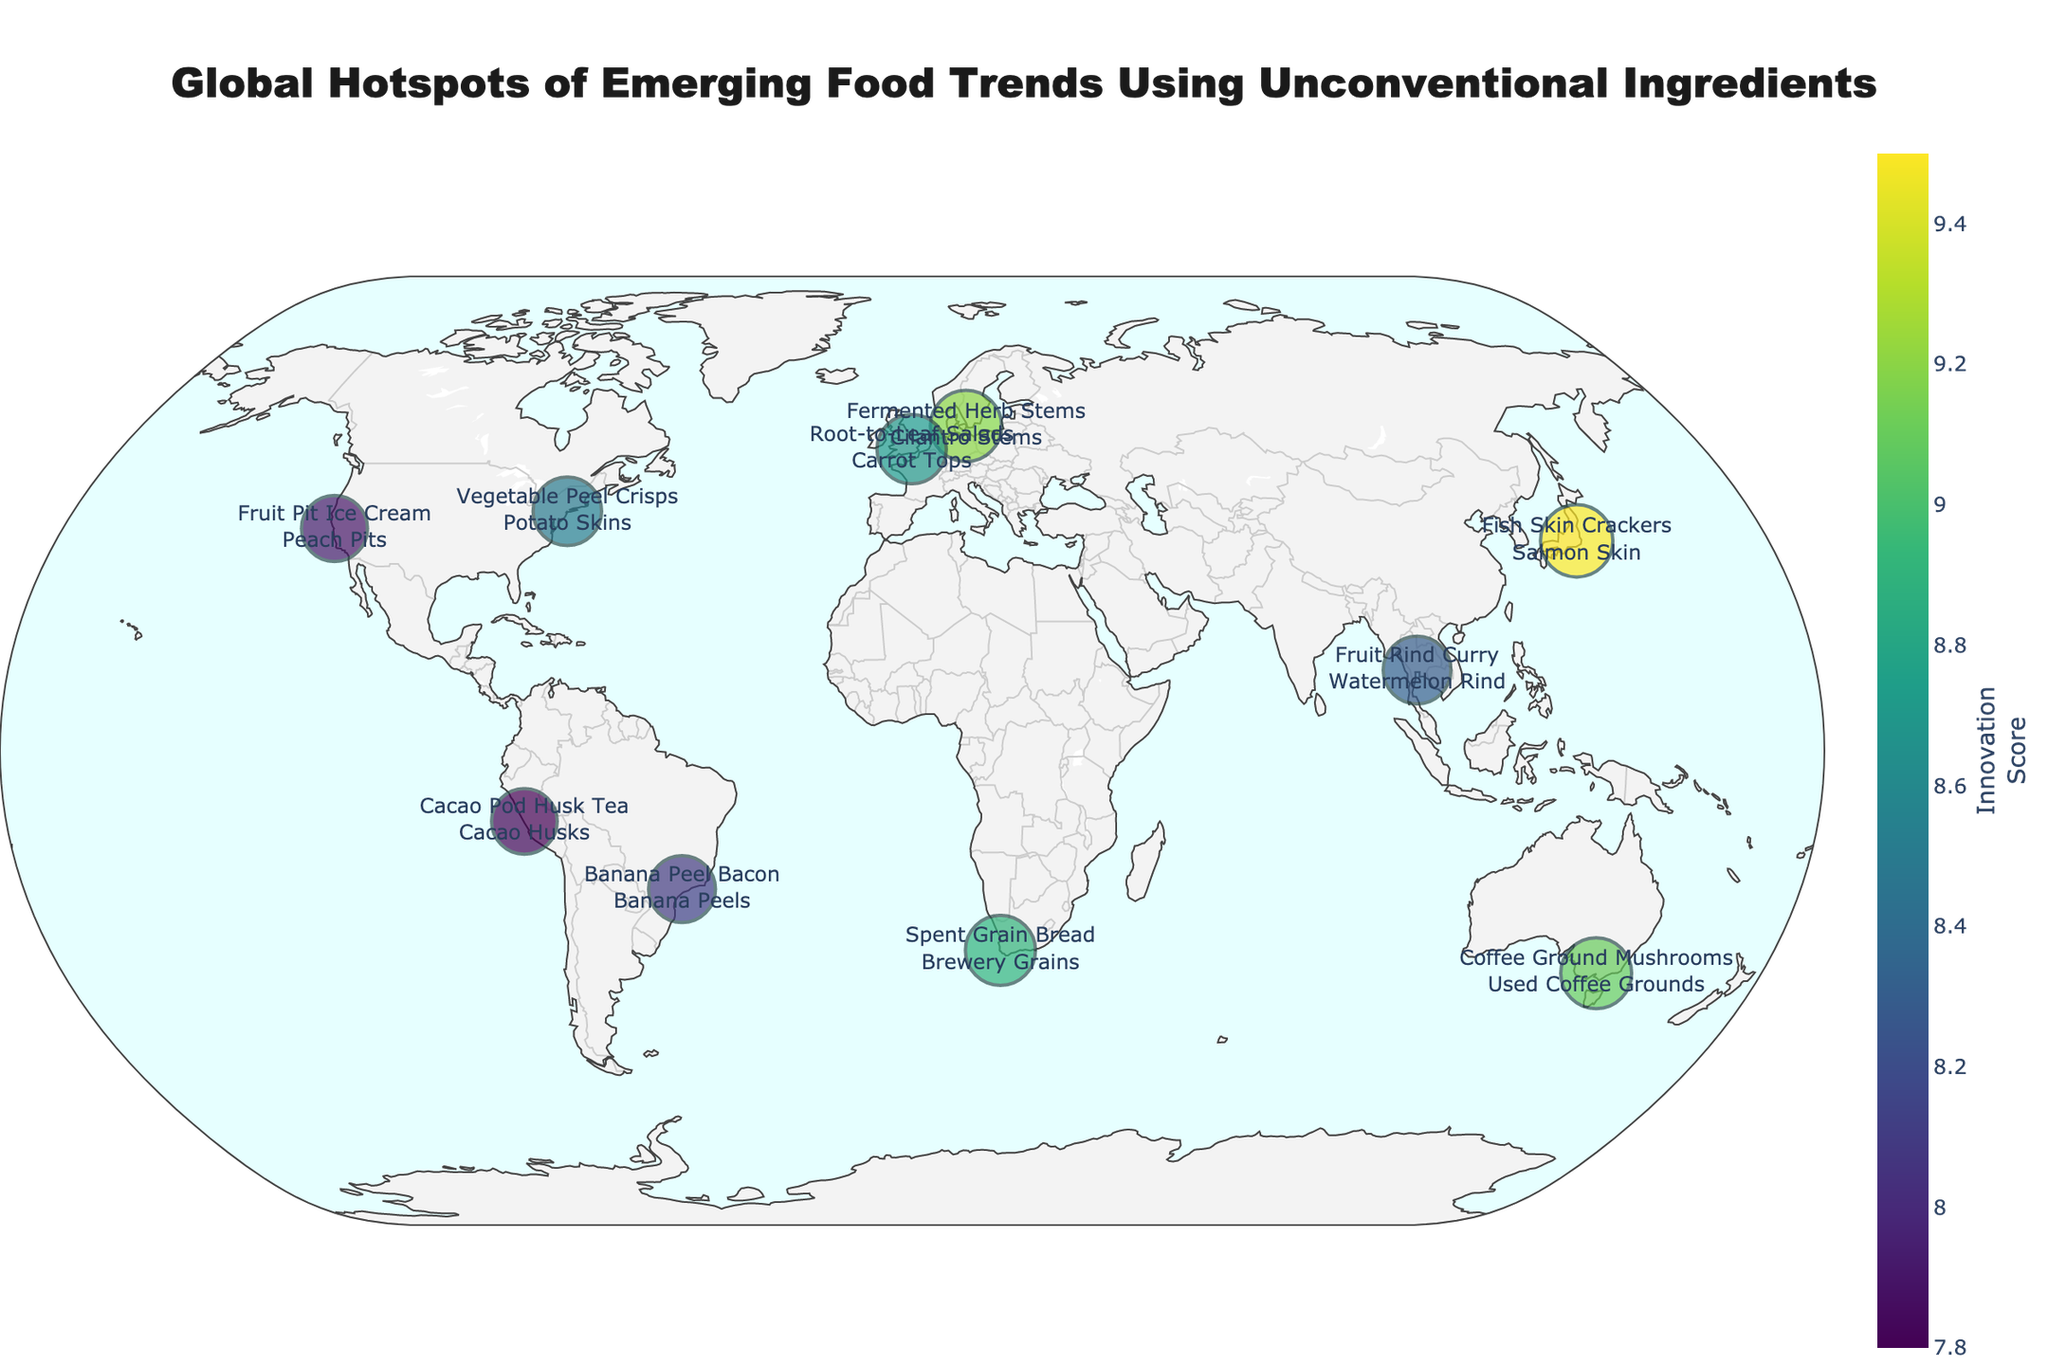What is the title of the plot? The title is prominently displayed at the top center of the plot. It reads "Global Hotspots of Emerging Food Trends Using Unconventional Ingredients".
Answer: Global Hotspots of Emerging Food Trends Using Unconventional Ingredients How many cities are highlighted on the map? There are dots representing each city, and count them on the plot. There are 10 cities in total.
Answer: 10 Which city has the highest innovation score? The city with the largest dot is the one with the highest innovation score. Tokyo has the largest dot with the score of 9.5.
Answer: Tokyo What unconventional ingredient is used in Melbourne? Hover over the dot corresponding to Melbourne. The text shows "Coffee Ground Mushrooms" and "Used Coffee Grounds".
Answer: Used Coffee Grounds Which city in Europe has a higher innovation score, Copenhagen or London? Compare the sizes of the dots for Copenhagen and London. Copenhagen is 9.2 and London is 8.7; hence, Copenhagen has a higher innovation score.
Answer: Copenhagen What is the average innovation score of the cities in North America? Sum the innovation scores of New York (8.5) and San Francisco (7.9) and divide by 2. (8.5 + 7.9) / 2 = 8.2.
Answer: 8.2 Which continent has the most cities represented on the map? Count the number of cities per continent by observing the labels. North America and Asia each have 2 cities, Europe has 2, South America has 2, Africa has 1, and Australia has 1. North America and Asia both have the most with 2 cities each.
Answer: North America and Asia What type of food trend is emerging in Cape Town? Hover over the dot for Cape Town to see the trend description. It shows "Spent Grain Bread".
Answer: Spent Grain Bread How does the innovation score for Fish Skin Crackers in Tokyo compare to Coffee Ground Mushrooms in Melbourne? Observe the sizes and score values for Tokyo and Melbourne. Tokyo's score is 9.5 and Melbourne's score is 9.1, so Tokyo has a higher score.
Answer: Tokyo What is the total innovation score for all the cities? Add innovation scores of all cities: 8.5 + 7.9 + 9.2 + 8.7 + 9.5 + 8.3 + 7.8 + 8.1 + 8.9 + 9.1 = 86.
Answer: 86 